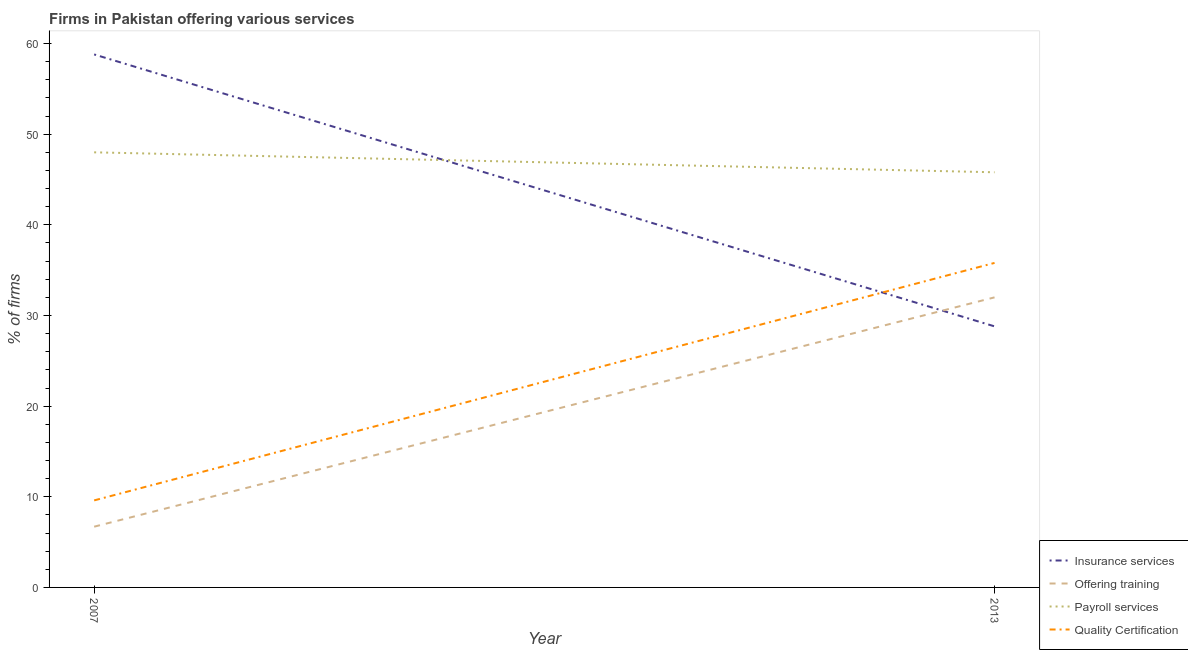How many different coloured lines are there?
Provide a short and direct response. 4. Does the line corresponding to percentage of firms offering training intersect with the line corresponding to percentage of firms offering payroll services?
Ensure brevity in your answer.  No. Is the number of lines equal to the number of legend labels?
Offer a very short reply. Yes. Across all years, what is the maximum percentage of firms offering insurance services?
Make the answer very short. 58.8. In which year was the percentage of firms offering training maximum?
Give a very brief answer. 2013. In which year was the percentage of firms offering quality certification minimum?
Your response must be concise. 2007. What is the total percentage of firms offering payroll services in the graph?
Provide a succinct answer. 93.8. What is the difference between the percentage of firms offering payroll services in 2007 and that in 2013?
Ensure brevity in your answer.  2.2. What is the difference between the percentage of firms offering quality certification in 2007 and the percentage of firms offering payroll services in 2013?
Provide a short and direct response. -36.2. What is the average percentage of firms offering quality certification per year?
Offer a very short reply. 22.7. In the year 2013, what is the difference between the percentage of firms offering training and percentage of firms offering payroll services?
Offer a very short reply. -13.8. In how many years, is the percentage of firms offering insurance services greater than 8 %?
Your answer should be compact. 2. What is the ratio of the percentage of firms offering training in 2007 to that in 2013?
Provide a succinct answer. 0.21. Is the percentage of firms offering insurance services in 2007 less than that in 2013?
Your response must be concise. No. Is the percentage of firms offering quality certification strictly less than the percentage of firms offering insurance services over the years?
Your answer should be compact. No. How many years are there in the graph?
Ensure brevity in your answer.  2. Where does the legend appear in the graph?
Make the answer very short. Bottom right. How many legend labels are there?
Make the answer very short. 4. How are the legend labels stacked?
Provide a succinct answer. Vertical. What is the title of the graph?
Your response must be concise. Firms in Pakistan offering various services . What is the label or title of the X-axis?
Give a very brief answer. Year. What is the label or title of the Y-axis?
Offer a very short reply. % of firms. What is the % of firms of Insurance services in 2007?
Provide a short and direct response. 58.8. What is the % of firms in Offering training in 2007?
Your answer should be compact. 6.7. What is the % of firms of Payroll services in 2007?
Make the answer very short. 48. What is the % of firms of Quality Certification in 2007?
Offer a terse response. 9.6. What is the % of firms in Insurance services in 2013?
Offer a very short reply. 28.8. What is the % of firms of Payroll services in 2013?
Give a very brief answer. 45.8. What is the % of firms of Quality Certification in 2013?
Give a very brief answer. 35.8. Across all years, what is the maximum % of firms of Insurance services?
Give a very brief answer. 58.8. Across all years, what is the maximum % of firms of Payroll services?
Provide a succinct answer. 48. Across all years, what is the maximum % of firms of Quality Certification?
Give a very brief answer. 35.8. Across all years, what is the minimum % of firms in Insurance services?
Offer a terse response. 28.8. Across all years, what is the minimum % of firms of Payroll services?
Your answer should be very brief. 45.8. What is the total % of firms of Insurance services in the graph?
Your answer should be compact. 87.6. What is the total % of firms of Offering training in the graph?
Your answer should be compact. 38.7. What is the total % of firms in Payroll services in the graph?
Your answer should be compact. 93.8. What is the total % of firms of Quality Certification in the graph?
Offer a terse response. 45.4. What is the difference between the % of firms in Insurance services in 2007 and that in 2013?
Your answer should be very brief. 30. What is the difference between the % of firms of Offering training in 2007 and that in 2013?
Ensure brevity in your answer.  -25.3. What is the difference between the % of firms in Payroll services in 2007 and that in 2013?
Make the answer very short. 2.2. What is the difference between the % of firms in Quality Certification in 2007 and that in 2013?
Provide a short and direct response. -26.2. What is the difference between the % of firms in Insurance services in 2007 and the % of firms in Offering training in 2013?
Your answer should be compact. 26.8. What is the difference between the % of firms in Insurance services in 2007 and the % of firms in Quality Certification in 2013?
Your answer should be very brief. 23. What is the difference between the % of firms of Offering training in 2007 and the % of firms of Payroll services in 2013?
Make the answer very short. -39.1. What is the difference between the % of firms in Offering training in 2007 and the % of firms in Quality Certification in 2013?
Your answer should be compact. -29.1. What is the difference between the % of firms in Payroll services in 2007 and the % of firms in Quality Certification in 2013?
Provide a succinct answer. 12.2. What is the average % of firms in Insurance services per year?
Offer a terse response. 43.8. What is the average % of firms in Offering training per year?
Give a very brief answer. 19.35. What is the average % of firms in Payroll services per year?
Ensure brevity in your answer.  46.9. What is the average % of firms of Quality Certification per year?
Offer a terse response. 22.7. In the year 2007, what is the difference between the % of firms of Insurance services and % of firms of Offering training?
Make the answer very short. 52.1. In the year 2007, what is the difference between the % of firms of Insurance services and % of firms of Payroll services?
Your answer should be very brief. 10.8. In the year 2007, what is the difference between the % of firms in Insurance services and % of firms in Quality Certification?
Your answer should be compact. 49.2. In the year 2007, what is the difference between the % of firms in Offering training and % of firms in Payroll services?
Your answer should be compact. -41.3. In the year 2007, what is the difference between the % of firms in Offering training and % of firms in Quality Certification?
Provide a short and direct response. -2.9. In the year 2007, what is the difference between the % of firms of Payroll services and % of firms of Quality Certification?
Offer a terse response. 38.4. In the year 2013, what is the difference between the % of firms in Insurance services and % of firms in Offering training?
Provide a short and direct response. -3.2. In the year 2013, what is the difference between the % of firms in Insurance services and % of firms in Quality Certification?
Offer a very short reply. -7. In the year 2013, what is the difference between the % of firms in Offering training and % of firms in Payroll services?
Offer a terse response. -13.8. In the year 2013, what is the difference between the % of firms in Offering training and % of firms in Quality Certification?
Make the answer very short. -3.8. In the year 2013, what is the difference between the % of firms in Payroll services and % of firms in Quality Certification?
Your answer should be very brief. 10. What is the ratio of the % of firms of Insurance services in 2007 to that in 2013?
Offer a very short reply. 2.04. What is the ratio of the % of firms of Offering training in 2007 to that in 2013?
Give a very brief answer. 0.21. What is the ratio of the % of firms of Payroll services in 2007 to that in 2013?
Your answer should be very brief. 1.05. What is the ratio of the % of firms of Quality Certification in 2007 to that in 2013?
Your response must be concise. 0.27. What is the difference between the highest and the second highest % of firms of Insurance services?
Your response must be concise. 30. What is the difference between the highest and the second highest % of firms in Offering training?
Your response must be concise. 25.3. What is the difference between the highest and the second highest % of firms in Quality Certification?
Keep it short and to the point. 26.2. What is the difference between the highest and the lowest % of firms in Offering training?
Ensure brevity in your answer.  25.3. What is the difference between the highest and the lowest % of firms in Quality Certification?
Provide a short and direct response. 26.2. 